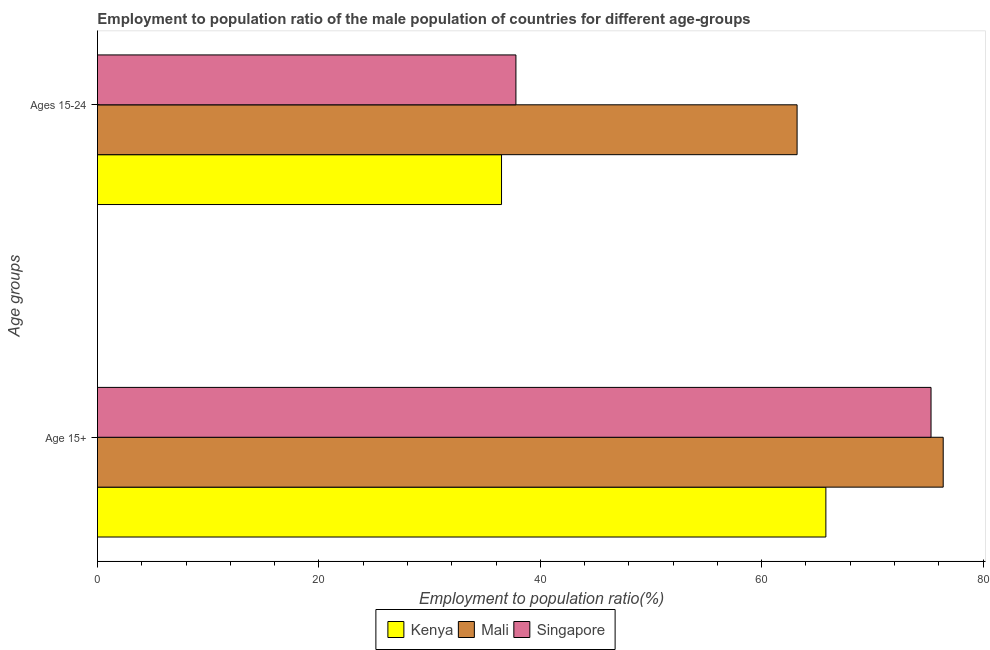How many different coloured bars are there?
Provide a short and direct response. 3. How many groups of bars are there?
Your answer should be very brief. 2. Are the number of bars on each tick of the Y-axis equal?
Your answer should be very brief. Yes. What is the label of the 1st group of bars from the top?
Your answer should be compact. Ages 15-24. What is the employment to population ratio(age 15-24) in Kenya?
Provide a short and direct response. 36.5. Across all countries, what is the maximum employment to population ratio(age 15-24)?
Offer a terse response. 63.2. Across all countries, what is the minimum employment to population ratio(age 15+)?
Make the answer very short. 65.8. In which country was the employment to population ratio(age 15-24) maximum?
Offer a terse response. Mali. In which country was the employment to population ratio(age 15-24) minimum?
Offer a very short reply. Kenya. What is the total employment to population ratio(age 15+) in the graph?
Ensure brevity in your answer.  217.5. What is the difference between the employment to population ratio(age 15-24) in Kenya and that in Mali?
Your answer should be compact. -26.7. What is the difference between the employment to population ratio(age 15+) in Singapore and the employment to population ratio(age 15-24) in Kenya?
Keep it short and to the point. 38.8. What is the average employment to population ratio(age 15+) per country?
Keep it short and to the point. 72.5. What is the difference between the employment to population ratio(age 15+) and employment to population ratio(age 15-24) in Singapore?
Provide a succinct answer. 37.5. In how many countries, is the employment to population ratio(age 15+) greater than 64 %?
Keep it short and to the point. 3. What is the ratio of the employment to population ratio(age 15-24) in Kenya to that in Singapore?
Ensure brevity in your answer.  0.97. Is the employment to population ratio(age 15-24) in Kenya less than that in Singapore?
Provide a succinct answer. Yes. In how many countries, is the employment to population ratio(age 15-24) greater than the average employment to population ratio(age 15-24) taken over all countries?
Make the answer very short. 1. What does the 2nd bar from the top in Age 15+ represents?
Provide a succinct answer. Mali. What does the 2nd bar from the bottom in Age 15+ represents?
Provide a short and direct response. Mali. Does the graph contain grids?
Your response must be concise. No. Where does the legend appear in the graph?
Your answer should be compact. Bottom center. What is the title of the graph?
Ensure brevity in your answer.  Employment to population ratio of the male population of countries for different age-groups. What is the label or title of the X-axis?
Offer a terse response. Employment to population ratio(%). What is the label or title of the Y-axis?
Give a very brief answer. Age groups. What is the Employment to population ratio(%) of Kenya in Age 15+?
Offer a terse response. 65.8. What is the Employment to population ratio(%) of Mali in Age 15+?
Provide a short and direct response. 76.4. What is the Employment to population ratio(%) in Singapore in Age 15+?
Your response must be concise. 75.3. What is the Employment to population ratio(%) of Kenya in Ages 15-24?
Ensure brevity in your answer.  36.5. What is the Employment to population ratio(%) of Mali in Ages 15-24?
Provide a succinct answer. 63.2. What is the Employment to population ratio(%) of Singapore in Ages 15-24?
Offer a very short reply. 37.8. Across all Age groups, what is the maximum Employment to population ratio(%) in Kenya?
Ensure brevity in your answer.  65.8. Across all Age groups, what is the maximum Employment to population ratio(%) of Mali?
Your answer should be compact. 76.4. Across all Age groups, what is the maximum Employment to population ratio(%) of Singapore?
Offer a terse response. 75.3. Across all Age groups, what is the minimum Employment to population ratio(%) in Kenya?
Provide a succinct answer. 36.5. Across all Age groups, what is the minimum Employment to population ratio(%) of Mali?
Provide a short and direct response. 63.2. Across all Age groups, what is the minimum Employment to population ratio(%) in Singapore?
Keep it short and to the point. 37.8. What is the total Employment to population ratio(%) of Kenya in the graph?
Give a very brief answer. 102.3. What is the total Employment to population ratio(%) of Mali in the graph?
Make the answer very short. 139.6. What is the total Employment to population ratio(%) of Singapore in the graph?
Keep it short and to the point. 113.1. What is the difference between the Employment to population ratio(%) of Kenya in Age 15+ and that in Ages 15-24?
Your answer should be very brief. 29.3. What is the difference between the Employment to population ratio(%) in Mali in Age 15+ and that in Ages 15-24?
Give a very brief answer. 13.2. What is the difference between the Employment to population ratio(%) in Singapore in Age 15+ and that in Ages 15-24?
Your response must be concise. 37.5. What is the difference between the Employment to population ratio(%) of Kenya in Age 15+ and the Employment to population ratio(%) of Mali in Ages 15-24?
Provide a short and direct response. 2.6. What is the difference between the Employment to population ratio(%) of Kenya in Age 15+ and the Employment to population ratio(%) of Singapore in Ages 15-24?
Your answer should be very brief. 28. What is the difference between the Employment to population ratio(%) of Mali in Age 15+ and the Employment to population ratio(%) of Singapore in Ages 15-24?
Your answer should be compact. 38.6. What is the average Employment to population ratio(%) in Kenya per Age groups?
Offer a very short reply. 51.15. What is the average Employment to population ratio(%) of Mali per Age groups?
Give a very brief answer. 69.8. What is the average Employment to population ratio(%) in Singapore per Age groups?
Provide a short and direct response. 56.55. What is the difference between the Employment to population ratio(%) of Kenya and Employment to population ratio(%) of Mali in Age 15+?
Offer a terse response. -10.6. What is the difference between the Employment to population ratio(%) of Kenya and Employment to population ratio(%) of Singapore in Age 15+?
Keep it short and to the point. -9.5. What is the difference between the Employment to population ratio(%) of Kenya and Employment to population ratio(%) of Mali in Ages 15-24?
Offer a very short reply. -26.7. What is the difference between the Employment to population ratio(%) in Kenya and Employment to population ratio(%) in Singapore in Ages 15-24?
Make the answer very short. -1.3. What is the difference between the Employment to population ratio(%) of Mali and Employment to population ratio(%) of Singapore in Ages 15-24?
Ensure brevity in your answer.  25.4. What is the ratio of the Employment to population ratio(%) of Kenya in Age 15+ to that in Ages 15-24?
Provide a succinct answer. 1.8. What is the ratio of the Employment to population ratio(%) of Mali in Age 15+ to that in Ages 15-24?
Give a very brief answer. 1.21. What is the ratio of the Employment to population ratio(%) of Singapore in Age 15+ to that in Ages 15-24?
Make the answer very short. 1.99. What is the difference between the highest and the second highest Employment to population ratio(%) of Kenya?
Provide a succinct answer. 29.3. What is the difference between the highest and the second highest Employment to population ratio(%) of Mali?
Your answer should be compact. 13.2. What is the difference between the highest and the second highest Employment to population ratio(%) in Singapore?
Offer a very short reply. 37.5. What is the difference between the highest and the lowest Employment to population ratio(%) in Kenya?
Make the answer very short. 29.3. What is the difference between the highest and the lowest Employment to population ratio(%) in Singapore?
Provide a short and direct response. 37.5. 